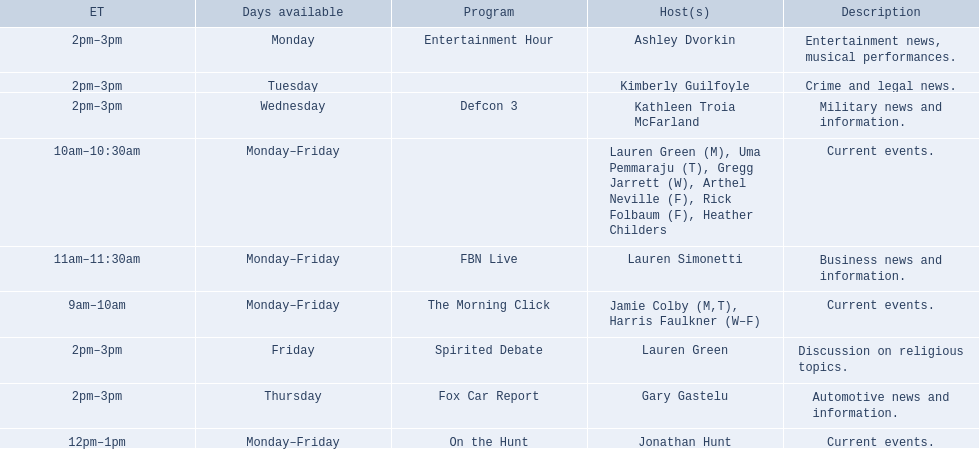What are the names of all the hosts? Jamie Colby (M,T), Harris Faulkner (W–F), Lauren Green (M), Uma Pemmaraju (T), Gregg Jarrett (W), Arthel Neville (F), Rick Folbaum (F), Heather Childers, Lauren Simonetti, Jonathan Hunt, Ashley Dvorkin, Kimberly Guilfoyle, Kathleen Troia McFarland, Gary Gastelu, Lauren Green. What hosts have a show on friday? Jamie Colby (M,T), Harris Faulkner (W–F), Lauren Green (M), Uma Pemmaraju (T), Gregg Jarrett (W), Arthel Neville (F), Rick Folbaum (F), Heather Childers, Lauren Simonetti, Jonathan Hunt, Lauren Green. Of these hosts, which is the only host with only friday available? Lauren Green. 